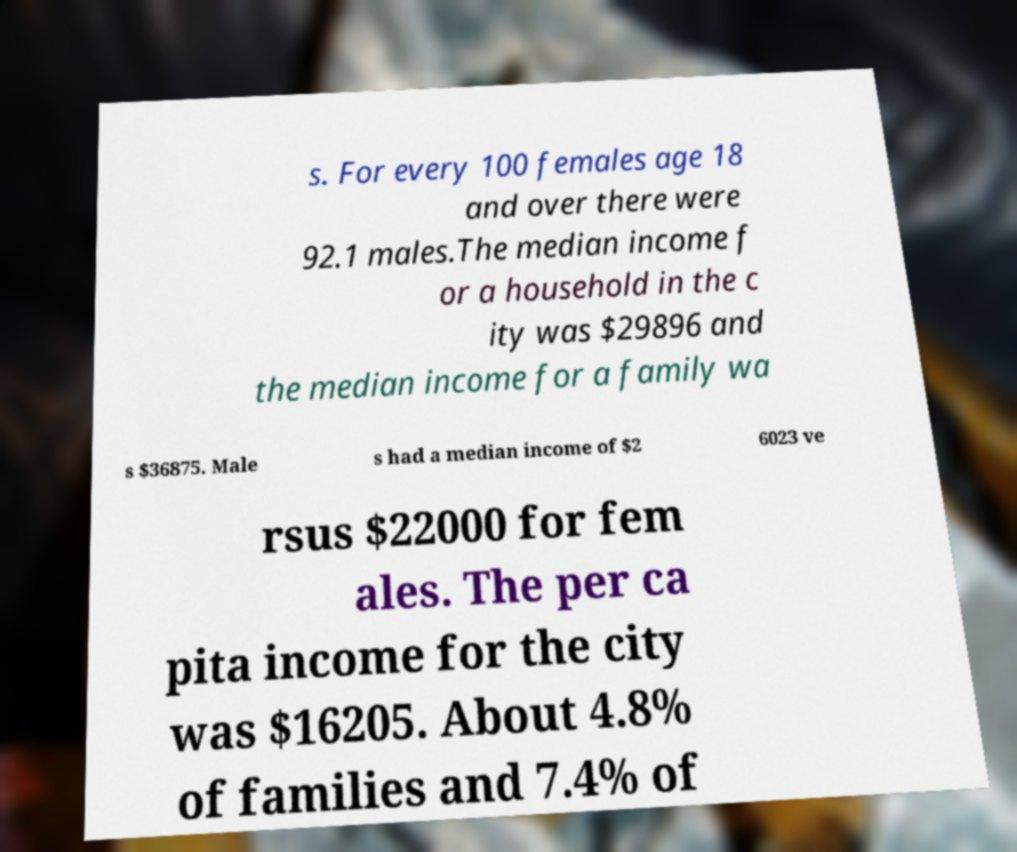Please identify and transcribe the text found in this image. s. For every 100 females age 18 and over there were 92.1 males.The median income f or a household in the c ity was $29896 and the median income for a family wa s $36875. Male s had a median income of $2 6023 ve rsus $22000 for fem ales. The per ca pita income for the city was $16205. About 4.8% of families and 7.4% of 